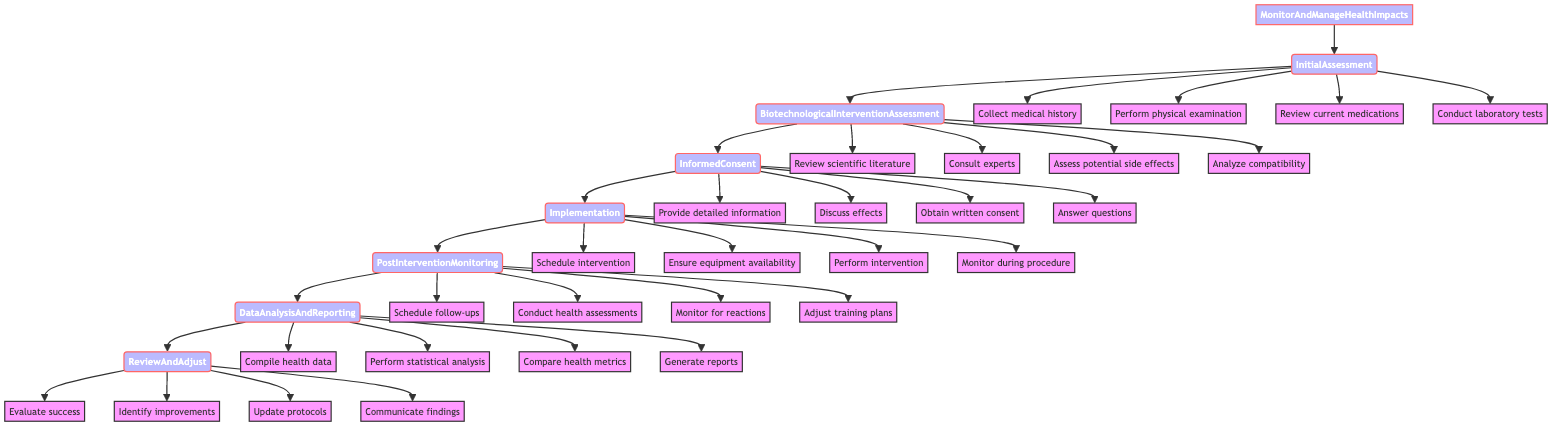What is the first step in the protocol? The first step in the protocol, as indicated by the flowchart, is "InitialAssessment." This is the starting point of the process to monitor and manage health impacts.
Answer: InitialAssessment How many actions are listed under PostInterventionMonitoring? There are four actions listed under PostInterventionMonitoring: "Schedule regular follow-up appointments," "Conduct periodic health assessments," "Monitor for any adverse reactions," and "Adjust training and nutrition plans as necessary." Therefore, counting these gives a total of four actions.
Answer: Four What step comes directly after InformedConsent? The step that follows InformedConsent in the sequence is "Implementation," as shown in the flowchart where arrows lead from InformedConsent to Implementation.
Answer: Implementation What is the primary focus of the BiotechnologicalInterventionAssessment step? The primary focus of the BiotechnologicalInterventionAssessment step is to evaluate the suitability and potential risks of the proposed biotechnological intervention. This is outlined in the description associated with that step.
Answer: Suitability and potential risks After DataAnalysisAndReporting, what is the next step? The flowchart shows that the next step following DataAnalysisAndReporting is "ReviewAndAdjust," indicating the continuation of the protocol after data analysis is complete.
Answer: ReviewAndAdjust How many total steps are outlined in the protocol? The diagram explicitly shows a total of seven steps from MonitorAndManageHealthImpacts to ReviewAndAdjust, confirming that there are seven sequential steps in the protocol.
Answer: Seven What are the first two actions under InitialAssessment? The first two actions listed under InitialAssessment are "Collect medical history" and "Perform physical examination," as seen in the branching under that step in the flowchart.
Answer: Collect medical history, Perform physical examination What is analyzed in the DataAnalysisAndReporting step? In the DataAnalysisAndReporting step, the collected health data is analyzed, which includes compiling the data, performing statistical analysis, comparing pre- and post-intervention health metrics, and generating reports.
Answer: Collected health data What does the ReviewAndAdjust step evaluate? The ReviewAndAdjust step evaluates the overall success of the intervention and identifies areas for improvement, as that is explicitly mentioned in the actions listed under this step in the diagram.
Answer: Overall success of the intervention 